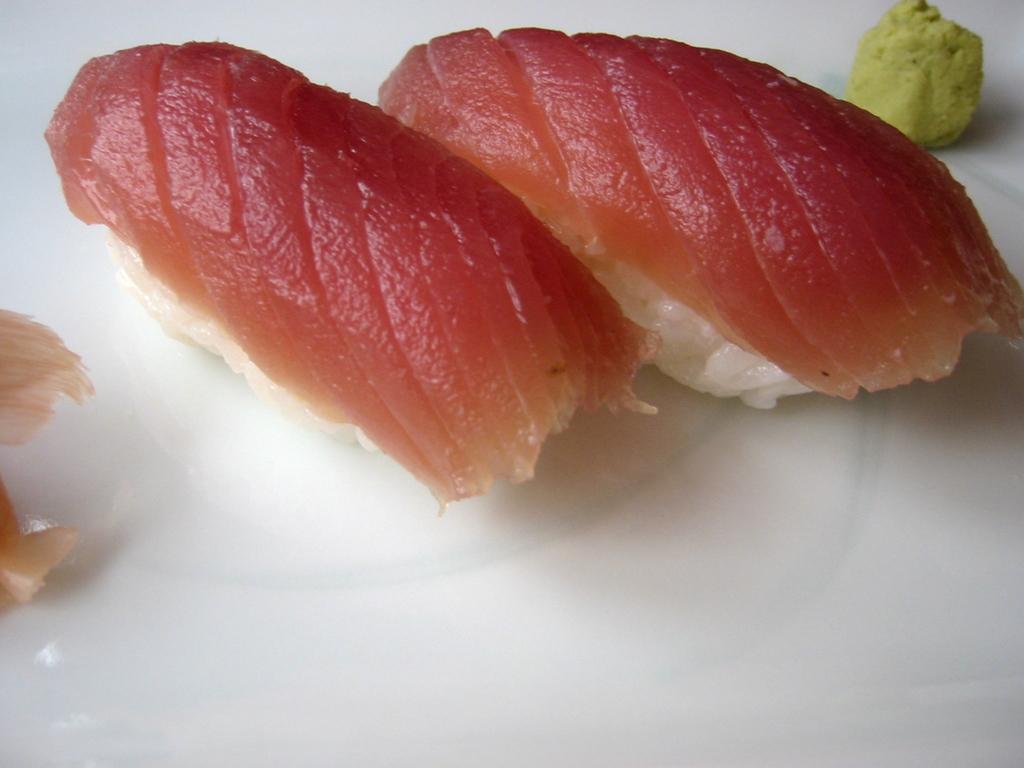Can you describe this image briefly? In the center of the image there is food placed on plate. 